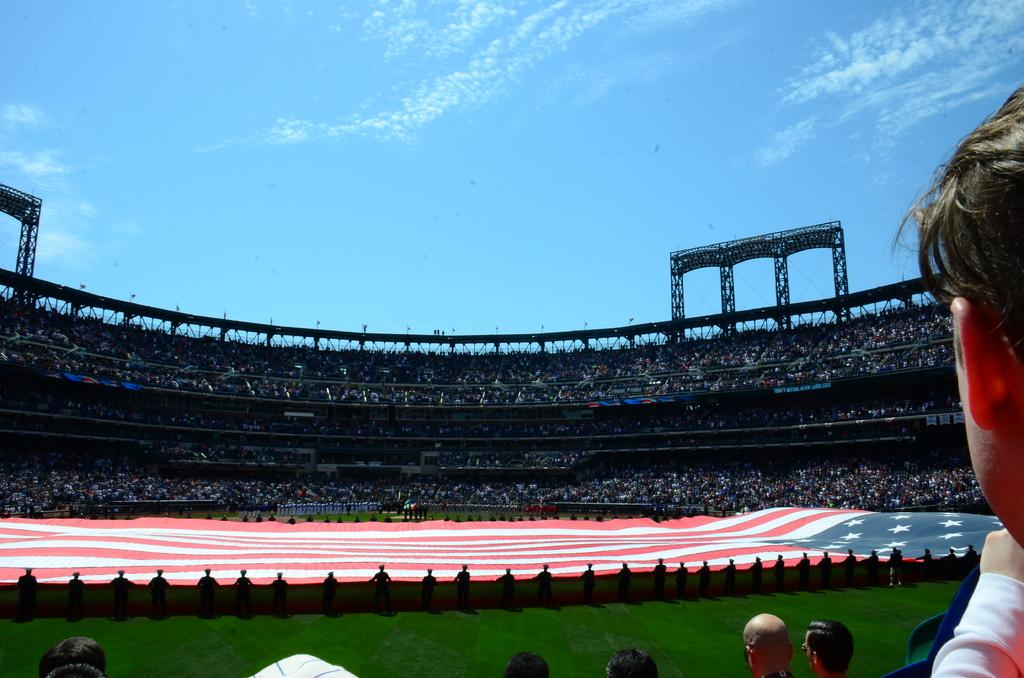What type of structure is visible in the image? There is a stadium in the image. What is happening inside or around the stadium? There is a crowd in the image, which suggests that an event is taking place. What can be seen flying or waving in the image? There is a flag in the image. What is the condition of the ground in the image? There are people on the ground in the image. What is visible at the top of the image? The sky is visible at the top of the image, and there are clouds in the sky. What direction is the bear walking in the image? There is no bear present in the image. What things are being sold in the image? The provided facts do not mention any items being sold in the image. 